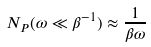Convert formula to latex. <formula><loc_0><loc_0><loc_500><loc_500>N _ { P } ( \omega \ll \beta ^ { - 1 } ) \approx \frac { 1 } { \beta \omega }</formula> 